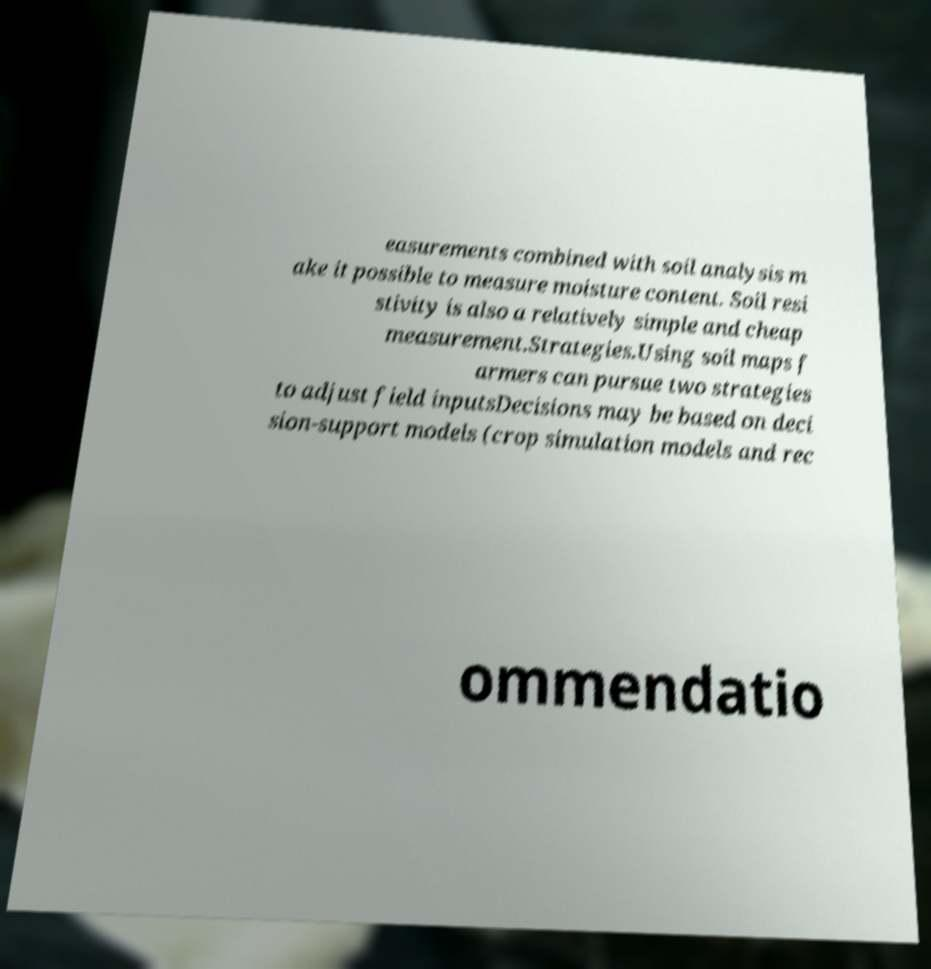Could you extract and type out the text from this image? easurements combined with soil analysis m ake it possible to measure moisture content. Soil resi stivity is also a relatively simple and cheap measurement.Strategies.Using soil maps f armers can pursue two strategies to adjust field inputsDecisions may be based on deci sion-support models (crop simulation models and rec ommendatio 